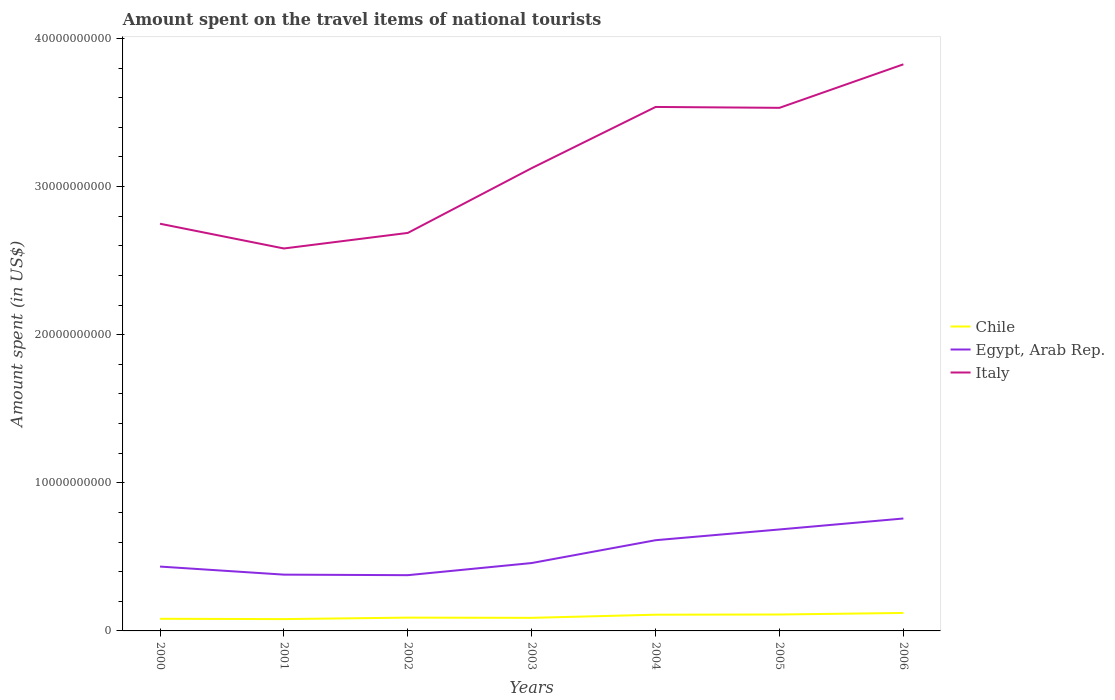How many different coloured lines are there?
Your answer should be very brief. 3. Across all years, what is the maximum amount spent on the travel items of national tourists in Chile?
Give a very brief answer. 7.99e+08. In which year was the amount spent on the travel items of national tourists in Chile maximum?
Offer a very short reply. 2001. What is the total amount spent on the travel items of national tourists in Italy in the graph?
Ensure brevity in your answer.  -1.24e+1. What is the difference between the highest and the second highest amount spent on the travel items of national tourists in Italy?
Make the answer very short. 1.24e+1. How many lines are there?
Your answer should be very brief. 3. How many legend labels are there?
Your response must be concise. 3. What is the title of the graph?
Your answer should be very brief. Amount spent on the travel items of national tourists. What is the label or title of the X-axis?
Provide a succinct answer. Years. What is the label or title of the Y-axis?
Ensure brevity in your answer.  Amount spent (in US$). What is the Amount spent (in US$) in Chile in 2000?
Your answer should be compact. 8.19e+08. What is the Amount spent (in US$) in Egypt, Arab Rep. in 2000?
Offer a terse response. 4.34e+09. What is the Amount spent (in US$) of Italy in 2000?
Offer a very short reply. 2.75e+1. What is the Amount spent (in US$) in Chile in 2001?
Provide a short and direct response. 7.99e+08. What is the Amount spent (in US$) of Egypt, Arab Rep. in 2001?
Provide a short and direct response. 3.80e+09. What is the Amount spent (in US$) of Italy in 2001?
Your answer should be compact. 2.58e+1. What is the Amount spent (in US$) in Chile in 2002?
Provide a short and direct response. 8.98e+08. What is the Amount spent (in US$) in Egypt, Arab Rep. in 2002?
Provide a succinct answer. 3.76e+09. What is the Amount spent (in US$) of Italy in 2002?
Keep it short and to the point. 2.69e+1. What is the Amount spent (in US$) of Chile in 2003?
Your answer should be compact. 8.83e+08. What is the Amount spent (in US$) of Egypt, Arab Rep. in 2003?
Offer a very short reply. 4.58e+09. What is the Amount spent (in US$) of Italy in 2003?
Your answer should be compact. 3.12e+1. What is the Amount spent (in US$) in Chile in 2004?
Make the answer very short. 1.10e+09. What is the Amount spent (in US$) of Egypt, Arab Rep. in 2004?
Your answer should be very brief. 6.12e+09. What is the Amount spent (in US$) of Italy in 2004?
Provide a short and direct response. 3.54e+1. What is the Amount spent (in US$) of Chile in 2005?
Keep it short and to the point. 1.11e+09. What is the Amount spent (in US$) of Egypt, Arab Rep. in 2005?
Your response must be concise. 6.85e+09. What is the Amount spent (in US$) in Italy in 2005?
Keep it short and to the point. 3.53e+1. What is the Amount spent (in US$) of Chile in 2006?
Offer a very short reply. 1.21e+09. What is the Amount spent (in US$) of Egypt, Arab Rep. in 2006?
Your answer should be compact. 7.59e+09. What is the Amount spent (in US$) of Italy in 2006?
Your answer should be compact. 3.83e+1. Across all years, what is the maximum Amount spent (in US$) of Chile?
Provide a short and direct response. 1.21e+09. Across all years, what is the maximum Amount spent (in US$) in Egypt, Arab Rep.?
Provide a short and direct response. 7.59e+09. Across all years, what is the maximum Amount spent (in US$) of Italy?
Make the answer very short. 3.83e+1. Across all years, what is the minimum Amount spent (in US$) in Chile?
Your response must be concise. 7.99e+08. Across all years, what is the minimum Amount spent (in US$) of Egypt, Arab Rep.?
Provide a succinct answer. 3.76e+09. Across all years, what is the minimum Amount spent (in US$) of Italy?
Your answer should be compact. 2.58e+1. What is the total Amount spent (in US$) of Chile in the graph?
Your response must be concise. 6.82e+09. What is the total Amount spent (in US$) of Egypt, Arab Rep. in the graph?
Ensure brevity in your answer.  3.71e+1. What is the total Amount spent (in US$) in Italy in the graph?
Your answer should be compact. 2.20e+11. What is the difference between the Amount spent (in US$) in Chile in 2000 and that in 2001?
Your answer should be compact. 2.00e+07. What is the difference between the Amount spent (in US$) of Egypt, Arab Rep. in 2000 and that in 2001?
Offer a very short reply. 5.45e+08. What is the difference between the Amount spent (in US$) of Italy in 2000 and that in 2001?
Your response must be concise. 1.67e+09. What is the difference between the Amount spent (in US$) in Chile in 2000 and that in 2002?
Give a very brief answer. -7.90e+07. What is the difference between the Amount spent (in US$) of Egypt, Arab Rep. in 2000 and that in 2002?
Make the answer very short. 5.81e+08. What is the difference between the Amount spent (in US$) of Italy in 2000 and that in 2002?
Ensure brevity in your answer.  6.20e+08. What is the difference between the Amount spent (in US$) of Chile in 2000 and that in 2003?
Keep it short and to the point. -6.40e+07. What is the difference between the Amount spent (in US$) in Egypt, Arab Rep. in 2000 and that in 2003?
Offer a very short reply. -2.39e+08. What is the difference between the Amount spent (in US$) of Italy in 2000 and that in 2003?
Ensure brevity in your answer.  -3.75e+09. What is the difference between the Amount spent (in US$) in Chile in 2000 and that in 2004?
Provide a succinct answer. -2.76e+08. What is the difference between the Amount spent (in US$) of Egypt, Arab Rep. in 2000 and that in 2004?
Your response must be concise. -1.78e+09. What is the difference between the Amount spent (in US$) in Italy in 2000 and that in 2004?
Your answer should be very brief. -7.88e+09. What is the difference between the Amount spent (in US$) of Chile in 2000 and that in 2005?
Make the answer very short. -2.90e+08. What is the difference between the Amount spent (in US$) in Egypt, Arab Rep. in 2000 and that in 2005?
Your answer should be very brief. -2.51e+09. What is the difference between the Amount spent (in US$) in Italy in 2000 and that in 2005?
Make the answer very short. -7.83e+09. What is the difference between the Amount spent (in US$) in Chile in 2000 and that in 2006?
Make the answer very short. -3.94e+08. What is the difference between the Amount spent (in US$) in Egypt, Arab Rep. in 2000 and that in 2006?
Provide a succinct answer. -3.25e+09. What is the difference between the Amount spent (in US$) in Italy in 2000 and that in 2006?
Offer a terse response. -1.08e+1. What is the difference between the Amount spent (in US$) of Chile in 2001 and that in 2002?
Offer a terse response. -9.90e+07. What is the difference between the Amount spent (in US$) of Egypt, Arab Rep. in 2001 and that in 2002?
Provide a succinct answer. 3.60e+07. What is the difference between the Amount spent (in US$) of Italy in 2001 and that in 2002?
Provide a short and direct response. -1.05e+09. What is the difference between the Amount spent (in US$) of Chile in 2001 and that in 2003?
Offer a very short reply. -8.40e+07. What is the difference between the Amount spent (in US$) of Egypt, Arab Rep. in 2001 and that in 2003?
Your response must be concise. -7.84e+08. What is the difference between the Amount spent (in US$) of Italy in 2001 and that in 2003?
Your response must be concise. -5.42e+09. What is the difference between the Amount spent (in US$) of Chile in 2001 and that in 2004?
Provide a succinct answer. -2.96e+08. What is the difference between the Amount spent (in US$) in Egypt, Arab Rep. in 2001 and that in 2004?
Offer a very short reply. -2.32e+09. What is the difference between the Amount spent (in US$) in Italy in 2001 and that in 2004?
Offer a terse response. -9.56e+09. What is the difference between the Amount spent (in US$) in Chile in 2001 and that in 2005?
Provide a short and direct response. -3.10e+08. What is the difference between the Amount spent (in US$) in Egypt, Arab Rep. in 2001 and that in 2005?
Your answer should be very brief. -3.05e+09. What is the difference between the Amount spent (in US$) in Italy in 2001 and that in 2005?
Your response must be concise. -9.50e+09. What is the difference between the Amount spent (in US$) of Chile in 2001 and that in 2006?
Your answer should be very brief. -4.14e+08. What is the difference between the Amount spent (in US$) in Egypt, Arab Rep. in 2001 and that in 2006?
Provide a succinct answer. -3.79e+09. What is the difference between the Amount spent (in US$) of Italy in 2001 and that in 2006?
Make the answer very short. -1.24e+1. What is the difference between the Amount spent (in US$) in Chile in 2002 and that in 2003?
Give a very brief answer. 1.50e+07. What is the difference between the Amount spent (in US$) of Egypt, Arab Rep. in 2002 and that in 2003?
Offer a very short reply. -8.20e+08. What is the difference between the Amount spent (in US$) in Italy in 2002 and that in 2003?
Keep it short and to the point. -4.37e+09. What is the difference between the Amount spent (in US$) in Chile in 2002 and that in 2004?
Provide a succinct answer. -1.97e+08. What is the difference between the Amount spent (in US$) of Egypt, Arab Rep. in 2002 and that in 2004?
Offer a very short reply. -2.36e+09. What is the difference between the Amount spent (in US$) in Italy in 2002 and that in 2004?
Give a very brief answer. -8.50e+09. What is the difference between the Amount spent (in US$) in Chile in 2002 and that in 2005?
Provide a short and direct response. -2.11e+08. What is the difference between the Amount spent (in US$) of Egypt, Arab Rep. in 2002 and that in 2005?
Provide a succinct answer. -3.09e+09. What is the difference between the Amount spent (in US$) in Italy in 2002 and that in 2005?
Your answer should be very brief. -8.45e+09. What is the difference between the Amount spent (in US$) of Chile in 2002 and that in 2006?
Your answer should be compact. -3.15e+08. What is the difference between the Amount spent (in US$) in Egypt, Arab Rep. in 2002 and that in 2006?
Provide a succinct answer. -3.83e+09. What is the difference between the Amount spent (in US$) of Italy in 2002 and that in 2006?
Offer a very short reply. -1.14e+1. What is the difference between the Amount spent (in US$) of Chile in 2003 and that in 2004?
Your answer should be compact. -2.12e+08. What is the difference between the Amount spent (in US$) in Egypt, Arab Rep. in 2003 and that in 2004?
Keep it short and to the point. -1.54e+09. What is the difference between the Amount spent (in US$) in Italy in 2003 and that in 2004?
Give a very brief answer. -4.13e+09. What is the difference between the Amount spent (in US$) in Chile in 2003 and that in 2005?
Offer a terse response. -2.26e+08. What is the difference between the Amount spent (in US$) in Egypt, Arab Rep. in 2003 and that in 2005?
Ensure brevity in your answer.  -2.27e+09. What is the difference between the Amount spent (in US$) in Italy in 2003 and that in 2005?
Your answer should be compact. -4.07e+09. What is the difference between the Amount spent (in US$) in Chile in 2003 and that in 2006?
Your answer should be compact. -3.30e+08. What is the difference between the Amount spent (in US$) in Egypt, Arab Rep. in 2003 and that in 2006?
Provide a succinct answer. -3.01e+09. What is the difference between the Amount spent (in US$) in Italy in 2003 and that in 2006?
Keep it short and to the point. -7.01e+09. What is the difference between the Amount spent (in US$) of Chile in 2004 and that in 2005?
Your answer should be very brief. -1.40e+07. What is the difference between the Amount spent (in US$) in Egypt, Arab Rep. in 2004 and that in 2005?
Offer a terse response. -7.26e+08. What is the difference between the Amount spent (in US$) of Italy in 2004 and that in 2005?
Make the answer very short. 5.90e+07. What is the difference between the Amount spent (in US$) of Chile in 2004 and that in 2006?
Provide a short and direct response. -1.18e+08. What is the difference between the Amount spent (in US$) of Egypt, Arab Rep. in 2004 and that in 2006?
Provide a succinct answer. -1.47e+09. What is the difference between the Amount spent (in US$) in Italy in 2004 and that in 2006?
Your answer should be compact. -2.88e+09. What is the difference between the Amount spent (in US$) in Chile in 2005 and that in 2006?
Your answer should be compact. -1.04e+08. What is the difference between the Amount spent (in US$) of Egypt, Arab Rep. in 2005 and that in 2006?
Offer a very short reply. -7.40e+08. What is the difference between the Amount spent (in US$) in Italy in 2005 and that in 2006?
Your answer should be compact. -2.94e+09. What is the difference between the Amount spent (in US$) in Chile in 2000 and the Amount spent (in US$) in Egypt, Arab Rep. in 2001?
Provide a short and direct response. -2.98e+09. What is the difference between the Amount spent (in US$) in Chile in 2000 and the Amount spent (in US$) in Italy in 2001?
Give a very brief answer. -2.50e+1. What is the difference between the Amount spent (in US$) in Egypt, Arab Rep. in 2000 and the Amount spent (in US$) in Italy in 2001?
Your answer should be compact. -2.15e+1. What is the difference between the Amount spent (in US$) of Chile in 2000 and the Amount spent (in US$) of Egypt, Arab Rep. in 2002?
Offer a very short reply. -2.94e+09. What is the difference between the Amount spent (in US$) in Chile in 2000 and the Amount spent (in US$) in Italy in 2002?
Give a very brief answer. -2.61e+1. What is the difference between the Amount spent (in US$) of Egypt, Arab Rep. in 2000 and the Amount spent (in US$) of Italy in 2002?
Provide a short and direct response. -2.25e+1. What is the difference between the Amount spent (in US$) in Chile in 2000 and the Amount spent (in US$) in Egypt, Arab Rep. in 2003?
Offer a terse response. -3.76e+09. What is the difference between the Amount spent (in US$) in Chile in 2000 and the Amount spent (in US$) in Italy in 2003?
Your answer should be very brief. -3.04e+1. What is the difference between the Amount spent (in US$) of Egypt, Arab Rep. in 2000 and the Amount spent (in US$) of Italy in 2003?
Ensure brevity in your answer.  -2.69e+1. What is the difference between the Amount spent (in US$) in Chile in 2000 and the Amount spent (in US$) in Egypt, Arab Rep. in 2004?
Offer a very short reply. -5.31e+09. What is the difference between the Amount spent (in US$) in Chile in 2000 and the Amount spent (in US$) in Italy in 2004?
Make the answer very short. -3.46e+1. What is the difference between the Amount spent (in US$) of Egypt, Arab Rep. in 2000 and the Amount spent (in US$) of Italy in 2004?
Ensure brevity in your answer.  -3.10e+1. What is the difference between the Amount spent (in US$) in Chile in 2000 and the Amount spent (in US$) in Egypt, Arab Rep. in 2005?
Ensure brevity in your answer.  -6.03e+09. What is the difference between the Amount spent (in US$) of Chile in 2000 and the Amount spent (in US$) of Italy in 2005?
Keep it short and to the point. -3.45e+1. What is the difference between the Amount spent (in US$) of Egypt, Arab Rep. in 2000 and the Amount spent (in US$) of Italy in 2005?
Offer a terse response. -3.10e+1. What is the difference between the Amount spent (in US$) of Chile in 2000 and the Amount spent (in US$) of Egypt, Arab Rep. in 2006?
Provide a succinct answer. -6.77e+09. What is the difference between the Amount spent (in US$) in Chile in 2000 and the Amount spent (in US$) in Italy in 2006?
Keep it short and to the point. -3.74e+1. What is the difference between the Amount spent (in US$) of Egypt, Arab Rep. in 2000 and the Amount spent (in US$) of Italy in 2006?
Your answer should be very brief. -3.39e+1. What is the difference between the Amount spent (in US$) of Chile in 2001 and the Amount spent (in US$) of Egypt, Arab Rep. in 2002?
Keep it short and to the point. -2.96e+09. What is the difference between the Amount spent (in US$) of Chile in 2001 and the Amount spent (in US$) of Italy in 2002?
Your answer should be compact. -2.61e+1. What is the difference between the Amount spent (in US$) in Egypt, Arab Rep. in 2001 and the Amount spent (in US$) in Italy in 2002?
Provide a succinct answer. -2.31e+1. What is the difference between the Amount spent (in US$) of Chile in 2001 and the Amount spent (in US$) of Egypt, Arab Rep. in 2003?
Keep it short and to the point. -3.78e+09. What is the difference between the Amount spent (in US$) in Chile in 2001 and the Amount spent (in US$) in Italy in 2003?
Your answer should be very brief. -3.04e+1. What is the difference between the Amount spent (in US$) of Egypt, Arab Rep. in 2001 and the Amount spent (in US$) of Italy in 2003?
Give a very brief answer. -2.74e+1. What is the difference between the Amount spent (in US$) in Chile in 2001 and the Amount spent (in US$) in Egypt, Arab Rep. in 2004?
Offer a very short reply. -5.33e+09. What is the difference between the Amount spent (in US$) in Chile in 2001 and the Amount spent (in US$) in Italy in 2004?
Keep it short and to the point. -3.46e+1. What is the difference between the Amount spent (in US$) in Egypt, Arab Rep. in 2001 and the Amount spent (in US$) in Italy in 2004?
Ensure brevity in your answer.  -3.16e+1. What is the difference between the Amount spent (in US$) of Chile in 2001 and the Amount spent (in US$) of Egypt, Arab Rep. in 2005?
Ensure brevity in your answer.  -6.05e+09. What is the difference between the Amount spent (in US$) in Chile in 2001 and the Amount spent (in US$) in Italy in 2005?
Make the answer very short. -3.45e+1. What is the difference between the Amount spent (in US$) of Egypt, Arab Rep. in 2001 and the Amount spent (in US$) of Italy in 2005?
Offer a very short reply. -3.15e+1. What is the difference between the Amount spent (in US$) of Chile in 2001 and the Amount spent (in US$) of Egypt, Arab Rep. in 2006?
Your response must be concise. -6.79e+09. What is the difference between the Amount spent (in US$) of Chile in 2001 and the Amount spent (in US$) of Italy in 2006?
Keep it short and to the point. -3.75e+1. What is the difference between the Amount spent (in US$) of Egypt, Arab Rep. in 2001 and the Amount spent (in US$) of Italy in 2006?
Keep it short and to the point. -3.45e+1. What is the difference between the Amount spent (in US$) in Chile in 2002 and the Amount spent (in US$) in Egypt, Arab Rep. in 2003?
Keep it short and to the point. -3.69e+09. What is the difference between the Amount spent (in US$) in Chile in 2002 and the Amount spent (in US$) in Italy in 2003?
Offer a very short reply. -3.03e+1. What is the difference between the Amount spent (in US$) of Egypt, Arab Rep. in 2002 and the Amount spent (in US$) of Italy in 2003?
Ensure brevity in your answer.  -2.75e+1. What is the difference between the Amount spent (in US$) in Chile in 2002 and the Amount spent (in US$) in Egypt, Arab Rep. in 2004?
Your answer should be very brief. -5.23e+09. What is the difference between the Amount spent (in US$) in Chile in 2002 and the Amount spent (in US$) in Italy in 2004?
Give a very brief answer. -3.45e+1. What is the difference between the Amount spent (in US$) in Egypt, Arab Rep. in 2002 and the Amount spent (in US$) in Italy in 2004?
Provide a short and direct response. -3.16e+1. What is the difference between the Amount spent (in US$) in Chile in 2002 and the Amount spent (in US$) in Egypt, Arab Rep. in 2005?
Keep it short and to the point. -5.95e+09. What is the difference between the Amount spent (in US$) in Chile in 2002 and the Amount spent (in US$) in Italy in 2005?
Provide a short and direct response. -3.44e+1. What is the difference between the Amount spent (in US$) of Egypt, Arab Rep. in 2002 and the Amount spent (in US$) of Italy in 2005?
Provide a succinct answer. -3.16e+1. What is the difference between the Amount spent (in US$) of Chile in 2002 and the Amount spent (in US$) of Egypt, Arab Rep. in 2006?
Make the answer very short. -6.69e+09. What is the difference between the Amount spent (in US$) of Chile in 2002 and the Amount spent (in US$) of Italy in 2006?
Provide a succinct answer. -3.74e+1. What is the difference between the Amount spent (in US$) in Egypt, Arab Rep. in 2002 and the Amount spent (in US$) in Italy in 2006?
Your answer should be very brief. -3.45e+1. What is the difference between the Amount spent (in US$) of Chile in 2003 and the Amount spent (in US$) of Egypt, Arab Rep. in 2004?
Provide a short and direct response. -5.24e+09. What is the difference between the Amount spent (in US$) in Chile in 2003 and the Amount spent (in US$) in Italy in 2004?
Provide a short and direct response. -3.45e+1. What is the difference between the Amount spent (in US$) of Egypt, Arab Rep. in 2003 and the Amount spent (in US$) of Italy in 2004?
Your answer should be very brief. -3.08e+1. What is the difference between the Amount spent (in US$) of Chile in 2003 and the Amount spent (in US$) of Egypt, Arab Rep. in 2005?
Provide a short and direct response. -5.97e+09. What is the difference between the Amount spent (in US$) of Chile in 2003 and the Amount spent (in US$) of Italy in 2005?
Your response must be concise. -3.44e+1. What is the difference between the Amount spent (in US$) of Egypt, Arab Rep. in 2003 and the Amount spent (in US$) of Italy in 2005?
Your response must be concise. -3.07e+1. What is the difference between the Amount spent (in US$) of Chile in 2003 and the Amount spent (in US$) of Egypt, Arab Rep. in 2006?
Give a very brief answer. -6.71e+09. What is the difference between the Amount spent (in US$) of Chile in 2003 and the Amount spent (in US$) of Italy in 2006?
Ensure brevity in your answer.  -3.74e+1. What is the difference between the Amount spent (in US$) of Egypt, Arab Rep. in 2003 and the Amount spent (in US$) of Italy in 2006?
Offer a very short reply. -3.37e+1. What is the difference between the Amount spent (in US$) in Chile in 2004 and the Amount spent (in US$) in Egypt, Arab Rep. in 2005?
Make the answer very short. -5.76e+09. What is the difference between the Amount spent (in US$) of Chile in 2004 and the Amount spent (in US$) of Italy in 2005?
Keep it short and to the point. -3.42e+1. What is the difference between the Amount spent (in US$) of Egypt, Arab Rep. in 2004 and the Amount spent (in US$) of Italy in 2005?
Your response must be concise. -2.92e+1. What is the difference between the Amount spent (in US$) of Chile in 2004 and the Amount spent (in US$) of Egypt, Arab Rep. in 2006?
Your answer should be very brief. -6.50e+09. What is the difference between the Amount spent (in US$) of Chile in 2004 and the Amount spent (in US$) of Italy in 2006?
Your answer should be very brief. -3.72e+1. What is the difference between the Amount spent (in US$) in Egypt, Arab Rep. in 2004 and the Amount spent (in US$) in Italy in 2006?
Provide a succinct answer. -3.21e+1. What is the difference between the Amount spent (in US$) of Chile in 2005 and the Amount spent (in US$) of Egypt, Arab Rep. in 2006?
Offer a very short reply. -6.48e+09. What is the difference between the Amount spent (in US$) of Chile in 2005 and the Amount spent (in US$) of Italy in 2006?
Offer a terse response. -3.71e+1. What is the difference between the Amount spent (in US$) of Egypt, Arab Rep. in 2005 and the Amount spent (in US$) of Italy in 2006?
Offer a very short reply. -3.14e+1. What is the average Amount spent (in US$) of Chile per year?
Your response must be concise. 9.74e+08. What is the average Amount spent (in US$) in Egypt, Arab Rep. per year?
Ensure brevity in your answer.  5.29e+09. What is the average Amount spent (in US$) in Italy per year?
Provide a short and direct response. 3.15e+1. In the year 2000, what is the difference between the Amount spent (in US$) of Chile and Amount spent (in US$) of Egypt, Arab Rep.?
Your answer should be very brief. -3.53e+09. In the year 2000, what is the difference between the Amount spent (in US$) in Chile and Amount spent (in US$) in Italy?
Offer a very short reply. -2.67e+1. In the year 2000, what is the difference between the Amount spent (in US$) of Egypt, Arab Rep. and Amount spent (in US$) of Italy?
Offer a very short reply. -2.31e+1. In the year 2001, what is the difference between the Amount spent (in US$) of Chile and Amount spent (in US$) of Egypt, Arab Rep.?
Offer a terse response. -3.00e+09. In the year 2001, what is the difference between the Amount spent (in US$) of Chile and Amount spent (in US$) of Italy?
Give a very brief answer. -2.50e+1. In the year 2001, what is the difference between the Amount spent (in US$) of Egypt, Arab Rep. and Amount spent (in US$) of Italy?
Give a very brief answer. -2.20e+1. In the year 2002, what is the difference between the Amount spent (in US$) in Chile and Amount spent (in US$) in Egypt, Arab Rep.?
Your answer should be very brief. -2.87e+09. In the year 2002, what is the difference between the Amount spent (in US$) in Chile and Amount spent (in US$) in Italy?
Make the answer very short. -2.60e+1. In the year 2002, what is the difference between the Amount spent (in US$) of Egypt, Arab Rep. and Amount spent (in US$) of Italy?
Keep it short and to the point. -2.31e+1. In the year 2003, what is the difference between the Amount spent (in US$) in Chile and Amount spent (in US$) in Egypt, Arab Rep.?
Offer a terse response. -3.70e+09. In the year 2003, what is the difference between the Amount spent (in US$) in Chile and Amount spent (in US$) in Italy?
Provide a short and direct response. -3.04e+1. In the year 2003, what is the difference between the Amount spent (in US$) in Egypt, Arab Rep. and Amount spent (in US$) in Italy?
Ensure brevity in your answer.  -2.67e+1. In the year 2004, what is the difference between the Amount spent (in US$) in Chile and Amount spent (in US$) in Egypt, Arab Rep.?
Offer a very short reply. -5.03e+09. In the year 2004, what is the difference between the Amount spent (in US$) in Chile and Amount spent (in US$) in Italy?
Keep it short and to the point. -3.43e+1. In the year 2004, what is the difference between the Amount spent (in US$) of Egypt, Arab Rep. and Amount spent (in US$) of Italy?
Give a very brief answer. -2.93e+1. In the year 2005, what is the difference between the Amount spent (in US$) in Chile and Amount spent (in US$) in Egypt, Arab Rep.?
Offer a terse response. -5.74e+09. In the year 2005, what is the difference between the Amount spent (in US$) of Chile and Amount spent (in US$) of Italy?
Your answer should be compact. -3.42e+1. In the year 2005, what is the difference between the Amount spent (in US$) of Egypt, Arab Rep. and Amount spent (in US$) of Italy?
Ensure brevity in your answer.  -2.85e+1. In the year 2006, what is the difference between the Amount spent (in US$) of Chile and Amount spent (in US$) of Egypt, Arab Rep.?
Offer a very short reply. -6.38e+09. In the year 2006, what is the difference between the Amount spent (in US$) of Chile and Amount spent (in US$) of Italy?
Offer a terse response. -3.70e+1. In the year 2006, what is the difference between the Amount spent (in US$) in Egypt, Arab Rep. and Amount spent (in US$) in Italy?
Offer a terse response. -3.07e+1. What is the ratio of the Amount spent (in US$) in Chile in 2000 to that in 2001?
Ensure brevity in your answer.  1.02. What is the ratio of the Amount spent (in US$) in Egypt, Arab Rep. in 2000 to that in 2001?
Offer a terse response. 1.14. What is the ratio of the Amount spent (in US$) in Italy in 2000 to that in 2001?
Keep it short and to the point. 1.06. What is the ratio of the Amount spent (in US$) in Chile in 2000 to that in 2002?
Keep it short and to the point. 0.91. What is the ratio of the Amount spent (in US$) of Egypt, Arab Rep. in 2000 to that in 2002?
Provide a succinct answer. 1.15. What is the ratio of the Amount spent (in US$) in Italy in 2000 to that in 2002?
Your response must be concise. 1.02. What is the ratio of the Amount spent (in US$) of Chile in 2000 to that in 2003?
Ensure brevity in your answer.  0.93. What is the ratio of the Amount spent (in US$) in Egypt, Arab Rep. in 2000 to that in 2003?
Offer a very short reply. 0.95. What is the ratio of the Amount spent (in US$) of Italy in 2000 to that in 2003?
Ensure brevity in your answer.  0.88. What is the ratio of the Amount spent (in US$) in Chile in 2000 to that in 2004?
Your response must be concise. 0.75. What is the ratio of the Amount spent (in US$) in Egypt, Arab Rep. in 2000 to that in 2004?
Ensure brevity in your answer.  0.71. What is the ratio of the Amount spent (in US$) of Italy in 2000 to that in 2004?
Your answer should be compact. 0.78. What is the ratio of the Amount spent (in US$) of Chile in 2000 to that in 2005?
Offer a terse response. 0.74. What is the ratio of the Amount spent (in US$) of Egypt, Arab Rep. in 2000 to that in 2005?
Ensure brevity in your answer.  0.63. What is the ratio of the Amount spent (in US$) in Italy in 2000 to that in 2005?
Offer a very short reply. 0.78. What is the ratio of the Amount spent (in US$) in Chile in 2000 to that in 2006?
Give a very brief answer. 0.68. What is the ratio of the Amount spent (in US$) in Egypt, Arab Rep. in 2000 to that in 2006?
Your response must be concise. 0.57. What is the ratio of the Amount spent (in US$) of Italy in 2000 to that in 2006?
Provide a short and direct response. 0.72. What is the ratio of the Amount spent (in US$) in Chile in 2001 to that in 2002?
Offer a terse response. 0.89. What is the ratio of the Amount spent (in US$) of Egypt, Arab Rep. in 2001 to that in 2002?
Give a very brief answer. 1.01. What is the ratio of the Amount spent (in US$) in Italy in 2001 to that in 2002?
Offer a terse response. 0.96. What is the ratio of the Amount spent (in US$) of Chile in 2001 to that in 2003?
Ensure brevity in your answer.  0.9. What is the ratio of the Amount spent (in US$) in Egypt, Arab Rep. in 2001 to that in 2003?
Give a very brief answer. 0.83. What is the ratio of the Amount spent (in US$) of Italy in 2001 to that in 2003?
Provide a short and direct response. 0.83. What is the ratio of the Amount spent (in US$) in Chile in 2001 to that in 2004?
Give a very brief answer. 0.73. What is the ratio of the Amount spent (in US$) in Egypt, Arab Rep. in 2001 to that in 2004?
Your response must be concise. 0.62. What is the ratio of the Amount spent (in US$) of Italy in 2001 to that in 2004?
Offer a terse response. 0.73. What is the ratio of the Amount spent (in US$) of Chile in 2001 to that in 2005?
Offer a terse response. 0.72. What is the ratio of the Amount spent (in US$) of Egypt, Arab Rep. in 2001 to that in 2005?
Provide a succinct answer. 0.55. What is the ratio of the Amount spent (in US$) of Italy in 2001 to that in 2005?
Offer a very short reply. 0.73. What is the ratio of the Amount spent (in US$) in Chile in 2001 to that in 2006?
Make the answer very short. 0.66. What is the ratio of the Amount spent (in US$) in Egypt, Arab Rep. in 2001 to that in 2006?
Provide a short and direct response. 0.5. What is the ratio of the Amount spent (in US$) in Italy in 2001 to that in 2006?
Give a very brief answer. 0.68. What is the ratio of the Amount spent (in US$) of Egypt, Arab Rep. in 2002 to that in 2003?
Offer a very short reply. 0.82. What is the ratio of the Amount spent (in US$) in Italy in 2002 to that in 2003?
Ensure brevity in your answer.  0.86. What is the ratio of the Amount spent (in US$) of Chile in 2002 to that in 2004?
Your answer should be very brief. 0.82. What is the ratio of the Amount spent (in US$) of Egypt, Arab Rep. in 2002 to that in 2004?
Provide a succinct answer. 0.61. What is the ratio of the Amount spent (in US$) of Italy in 2002 to that in 2004?
Provide a short and direct response. 0.76. What is the ratio of the Amount spent (in US$) in Chile in 2002 to that in 2005?
Your answer should be compact. 0.81. What is the ratio of the Amount spent (in US$) of Egypt, Arab Rep. in 2002 to that in 2005?
Keep it short and to the point. 0.55. What is the ratio of the Amount spent (in US$) in Italy in 2002 to that in 2005?
Ensure brevity in your answer.  0.76. What is the ratio of the Amount spent (in US$) in Chile in 2002 to that in 2006?
Ensure brevity in your answer.  0.74. What is the ratio of the Amount spent (in US$) in Egypt, Arab Rep. in 2002 to that in 2006?
Your response must be concise. 0.5. What is the ratio of the Amount spent (in US$) in Italy in 2002 to that in 2006?
Give a very brief answer. 0.7. What is the ratio of the Amount spent (in US$) of Chile in 2003 to that in 2004?
Offer a terse response. 0.81. What is the ratio of the Amount spent (in US$) of Egypt, Arab Rep. in 2003 to that in 2004?
Offer a very short reply. 0.75. What is the ratio of the Amount spent (in US$) of Italy in 2003 to that in 2004?
Provide a succinct answer. 0.88. What is the ratio of the Amount spent (in US$) of Chile in 2003 to that in 2005?
Keep it short and to the point. 0.8. What is the ratio of the Amount spent (in US$) of Egypt, Arab Rep. in 2003 to that in 2005?
Your response must be concise. 0.67. What is the ratio of the Amount spent (in US$) in Italy in 2003 to that in 2005?
Offer a terse response. 0.88. What is the ratio of the Amount spent (in US$) in Chile in 2003 to that in 2006?
Keep it short and to the point. 0.73. What is the ratio of the Amount spent (in US$) in Egypt, Arab Rep. in 2003 to that in 2006?
Make the answer very short. 0.6. What is the ratio of the Amount spent (in US$) in Italy in 2003 to that in 2006?
Provide a succinct answer. 0.82. What is the ratio of the Amount spent (in US$) of Chile in 2004 to that in 2005?
Your answer should be very brief. 0.99. What is the ratio of the Amount spent (in US$) in Egypt, Arab Rep. in 2004 to that in 2005?
Your response must be concise. 0.89. What is the ratio of the Amount spent (in US$) in Italy in 2004 to that in 2005?
Provide a succinct answer. 1. What is the ratio of the Amount spent (in US$) in Chile in 2004 to that in 2006?
Offer a very short reply. 0.9. What is the ratio of the Amount spent (in US$) of Egypt, Arab Rep. in 2004 to that in 2006?
Offer a very short reply. 0.81. What is the ratio of the Amount spent (in US$) of Italy in 2004 to that in 2006?
Provide a succinct answer. 0.92. What is the ratio of the Amount spent (in US$) in Chile in 2005 to that in 2006?
Provide a succinct answer. 0.91. What is the ratio of the Amount spent (in US$) of Egypt, Arab Rep. in 2005 to that in 2006?
Give a very brief answer. 0.9. What is the ratio of the Amount spent (in US$) of Italy in 2005 to that in 2006?
Your answer should be compact. 0.92. What is the difference between the highest and the second highest Amount spent (in US$) in Chile?
Offer a very short reply. 1.04e+08. What is the difference between the highest and the second highest Amount spent (in US$) of Egypt, Arab Rep.?
Provide a succinct answer. 7.40e+08. What is the difference between the highest and the second highest Amount spent (in US$) of Italy?
Your answer should be compact. 2.88e+09. What is the difference between the highest and the lowest Amount spent (in US$) of Chile?
Your answer should be very brief. 4.14e+08. What is the difference between the highest and the lowest Amount spent (in US$) of Egypt, Arab Rep.?
Make the answer very short. 3.83e+09. What is the difference between the highest and the lowest Amount spent (in US$) of Italy?
Ensure brevity in your answer.  1.24e+1. 